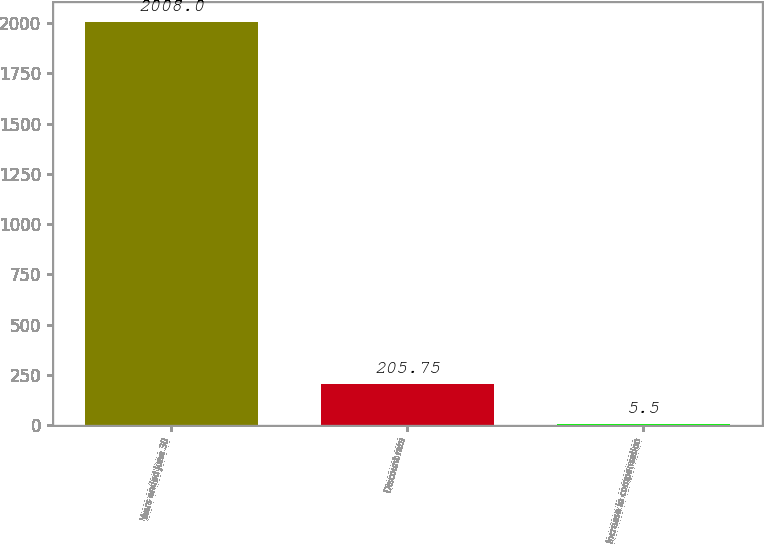Convert chart to OTSL. <chart><loc_0><loc_0><loc_500><loc_500><bar_chart><fcel>Years ended June 30<fcel>Discount rate<fcel>Increase in compensation<nl><fcel>2008<fcel>205.75<fcel>5.5<nl></chart> 